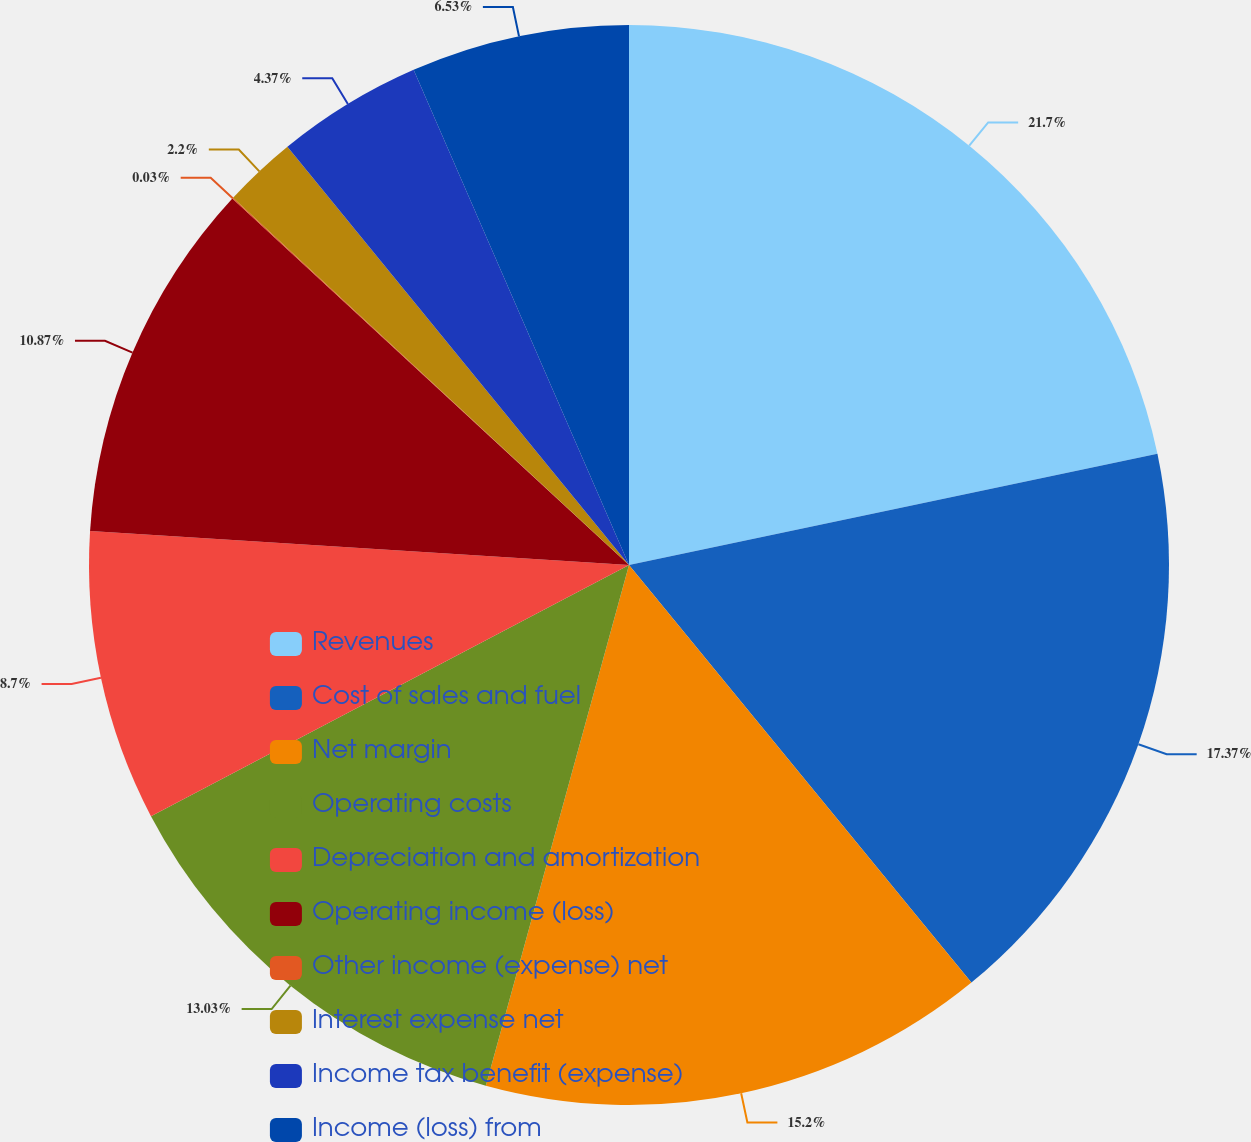Convert chart. <chart><loc_0><loc_0><loc_500><loc_500><pie_chart><fcel>Revenues<fcel>Cost of sales and fuel<fcel>Net margin<fcel>Operating costs<fcel>Depreciation and amortization<fcel>Operating income (loss)<fcel>Other income (expense) net<fcel>Interest expense net<fcel>Income tax benefit (expense)<fcel>Income (loss) from<nl><fcel>21.7%<fcel>17.37%<fcel>15.2%<fcel>13.03%<fcel>8.7%<fcel>10.87%<fcel>0.03%<fcel>2.2%<fcel>4.37%<fcel>6.53%<nl></chart> 